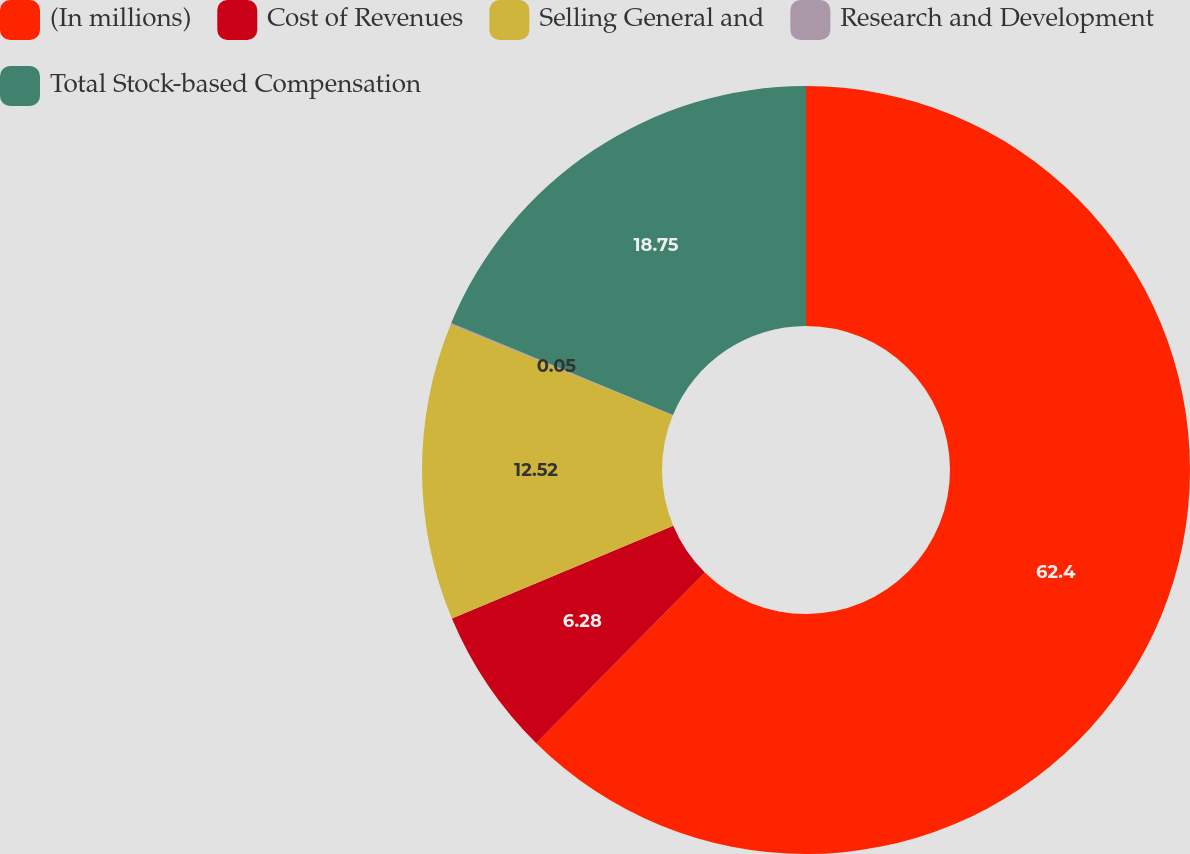Convert chart. <chart><loc_0><loc_0><loc_500><loc_500><pie_chart><fcel>(In millions)<fcel>Cost of Revenues<fcel>Selling General and<fcel>Research and Development<fcel>Total Stock-based Compensation<nl><fcel>62.39%<fcel>6.28%<fcel>12.52%<fcel>0.05%<fcel>18.75%<nl></chart> 